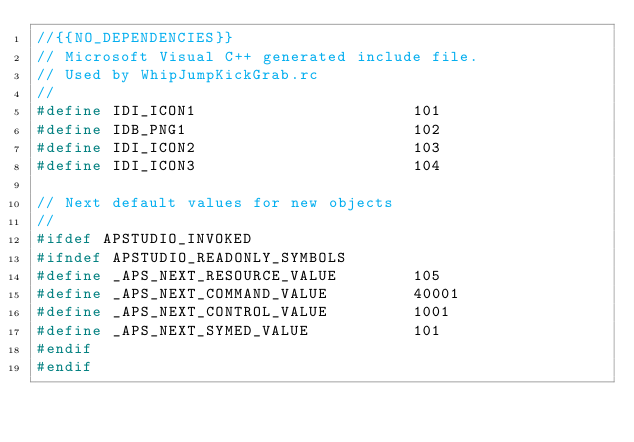Convert code to text. <code><loc_0><loc_0><loc_500><loc_500><_C_>//{{NO_DEPENDENCIES}}
// Microsoft Visual C++ generated include file.
// Used by WhipJumpKickGrab.rc
//
#define IDI_ICON1                       101
#define IDB_PNG1                        102
#define IDI_ICON2                       103
#define IDI_ICON3                       104

// Next default values for new objects
// 
#ifdef APSTUDIO_INVOKED
#ifndef APSTUDIO_READONLY_SYMBOLS
#define _APS_NEXT_RESOURCE_VALUE        105
#define _APS_NEXT_COMMAND_VALUE         40001
#define _APS_NEXT_CONTROL_VALUE         1001
#define _APS_NEXT_SYMED_VALUE           101
#endif
#endif
</code> 